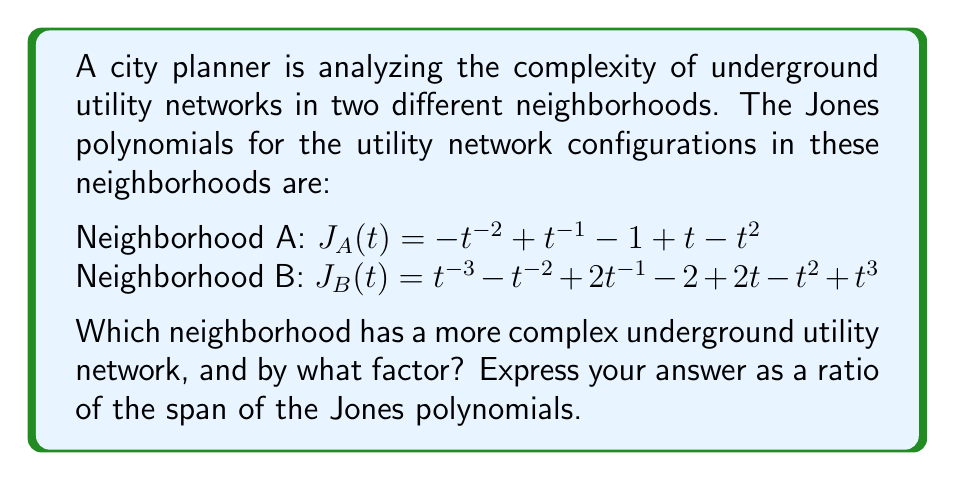Solve this math problem. To determine the complexity of the underground utility networks, we'll use the span of the Jones polynomials as a measure of complexity. The span is the difference between the highest and lowest exponents in the polynomial.

Step 1: Calculate the span for Neighborhood A's Jones polynomial.
$J_A(t) = -t^{-2} + t^{-1} - 1 + t - t^2$
Highest exponent: 2
Lowest exponent: -2
Span_A = 2 - (-2) = 4

Step 2: Calculate the span for Neighborhood B's Jones polynomial.
$J_B(t) = t^{-3} - t^{-2} + 2t^{-1} - 2 + 2t - t^2 + t^3$
Highest exponent: 3
Lowest exponent: -3
Span_B = 3 - (-3) = 6

Step 3: Compare the spans and calculate the ratio.
Ratio = Span_B / Span_A = 6 / 4 = 3 / 2

Step 4: Determine which neighborhood has the more complex network.
Since Span_B > Span_A, Neighborhood B has the more complex underground utility network.

Step 5: Express the factor of complexity as a ratio.
The factor of complexity is the ratio of the spans: 3:2
Answer: Neighborhood B; 3:2 